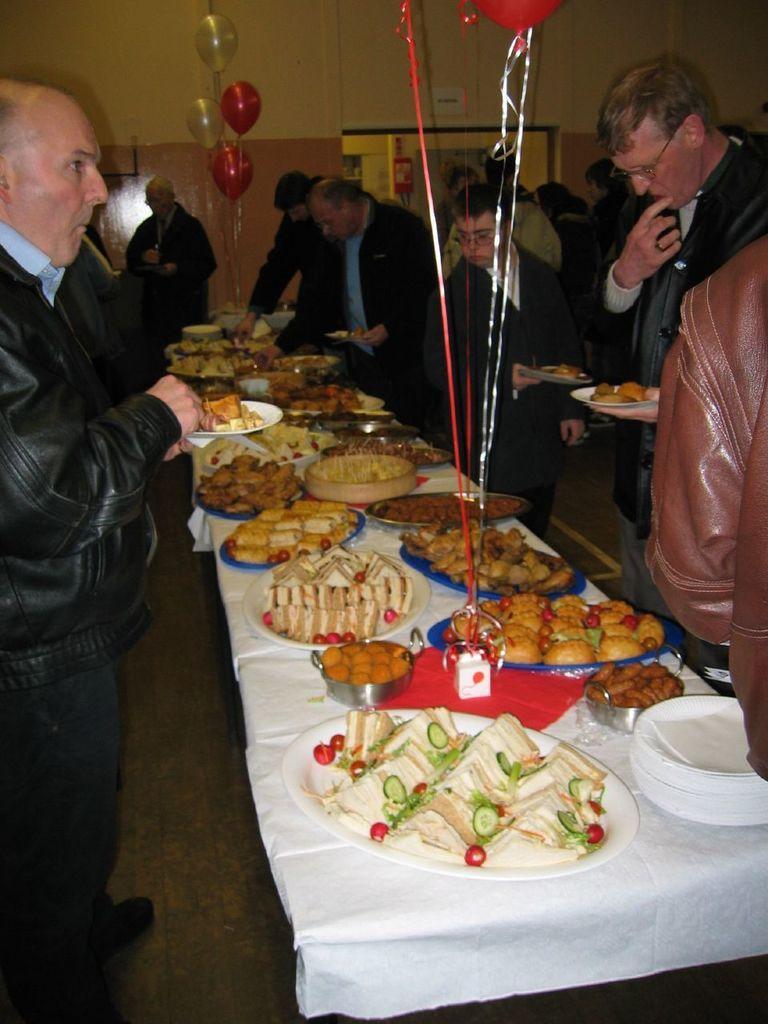In one or two sentences, can you explain what this image depicts? In this picture there is a long dining table at the right side of the image where there are different types of food items on it, and there are people standing around the dining table and they are eating. 